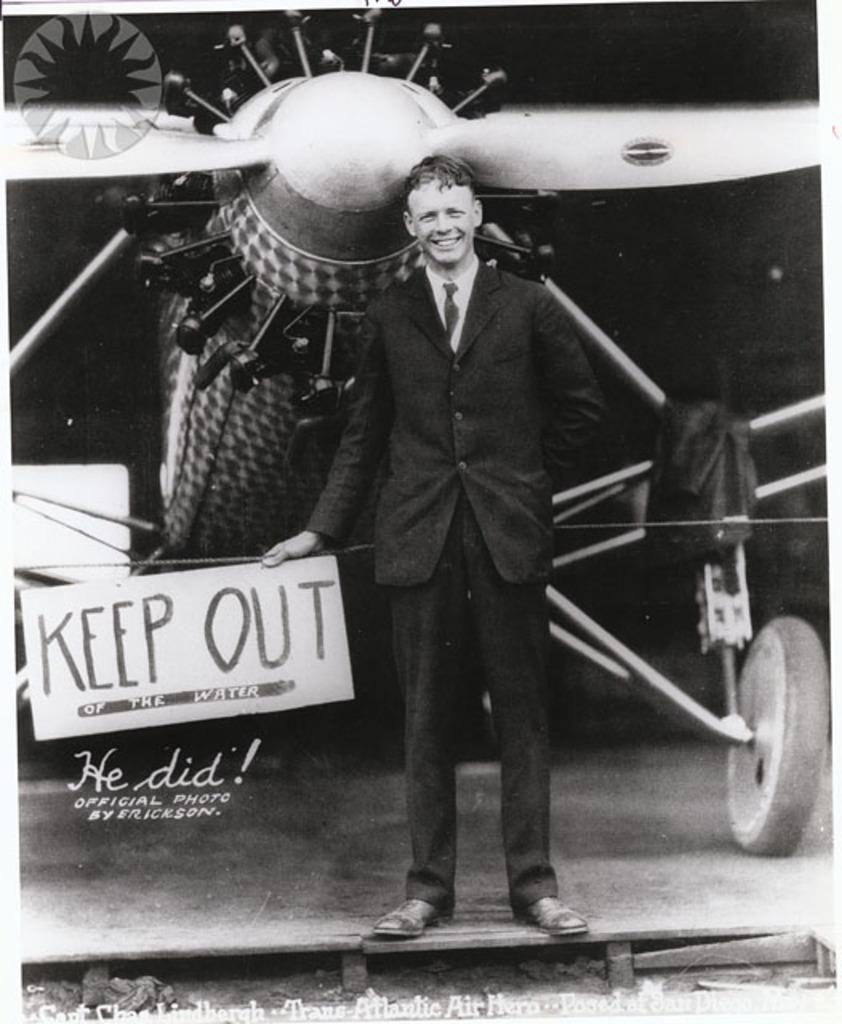What is the person in the image holding? The person is holding a placard with text in the image. What can be seen in the background behind the person? There is an aircraft behind the person. What type of information is present in the image? There is text and design present in the image. How many goldfish are swimming in the clouds in the image? There are no goldfish or clouds present in the image. 